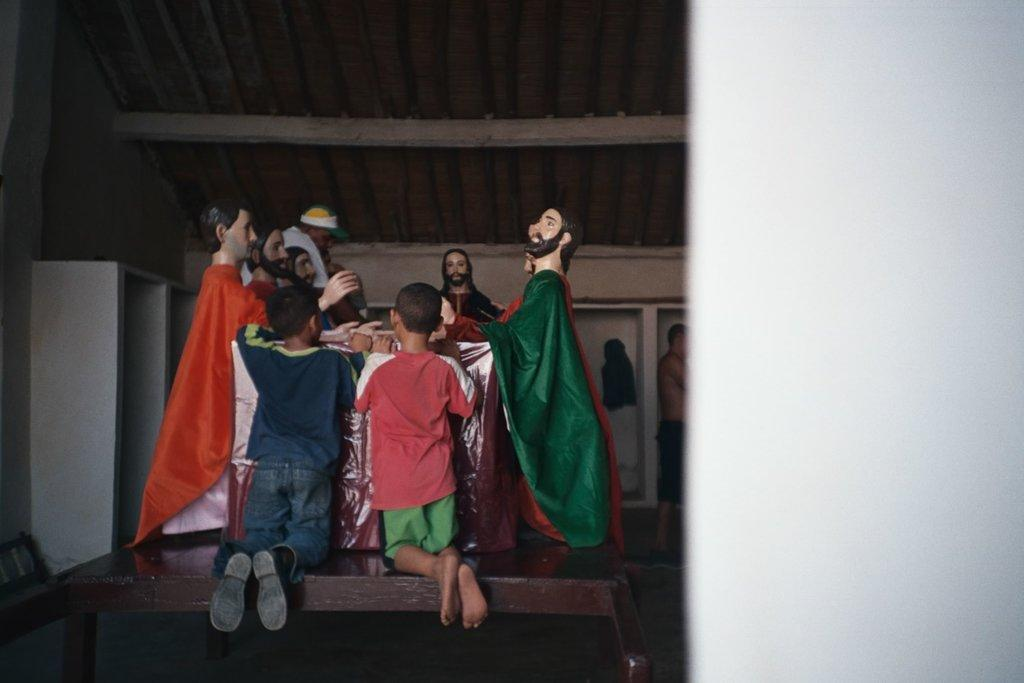What is the main piece of furniture in the image? There is a table in the image. What is placed on the table? There are statues on the table. Who is present in front of the statues? There are two kids in front of the statues. What is located behind the statues? There is a cupboard behind the statues. What can be seen at the top of the image? There are poles visible at the top of the image. What type of wool is being used to create the effect of the statues in the image? There is no wool present in the image, and the statues are not made of wool. 